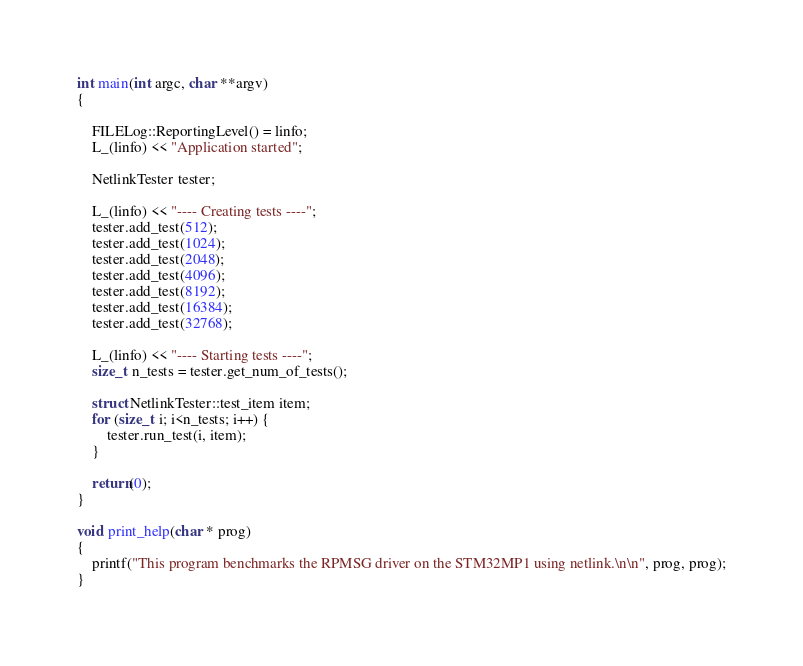Convert code to text. <code><loc_0><loc_0><loc_500><loc_500><_C++_>
int main(int argc, char **argv)
{

    FILELog::ReportingLevel() = linfo;
    L_(linfo) << "Application started";

    NetlinkTester tester;

    L_(linfo) << "---- Creating tests ----";
    tester.add_test(512);
    tester.add_test(1024);
    tester.add_test(2048);
    tester.add_test(4096);
    tester.add_test(8192);
    tester.add_test(16384);
    tester.add_test(32768);

    L_(linfo) << "---- Starting tests ----";
    size_t n_tests = tester.get_num_of_tests();

    struct NetlinkTester::test_item item;
    for (size_t i; i<n_tests; i++) {
        tester.run_test(i, item);
    }

    return(0);
}

void print_help(char * prog)
{
    printf("This program benchmarks the RPMSG driver on the STM32MP1 using netlink.\n\n", prog, prog);
}
</code> 